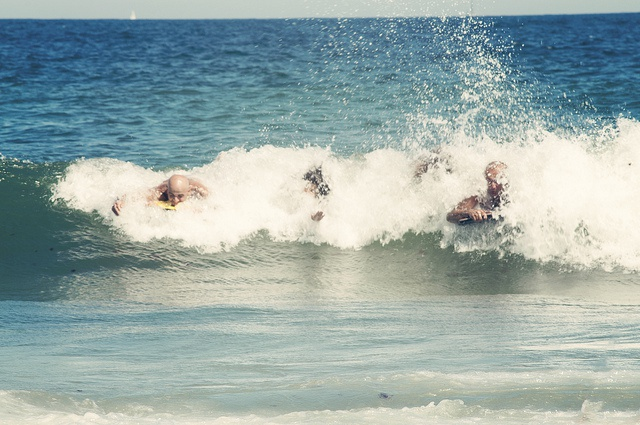Describe the objects in this image and their specific colors. I can see people in lightgray, beige, gray, and darkgray tones, people in lightgray, beige, tan, and gray tones, people in lightgray, beige, and darkgray tones, surfboard in beige, lightgray, and ivory tones, and people in lightgray, beige, darkgray, and gray tones in this image. 